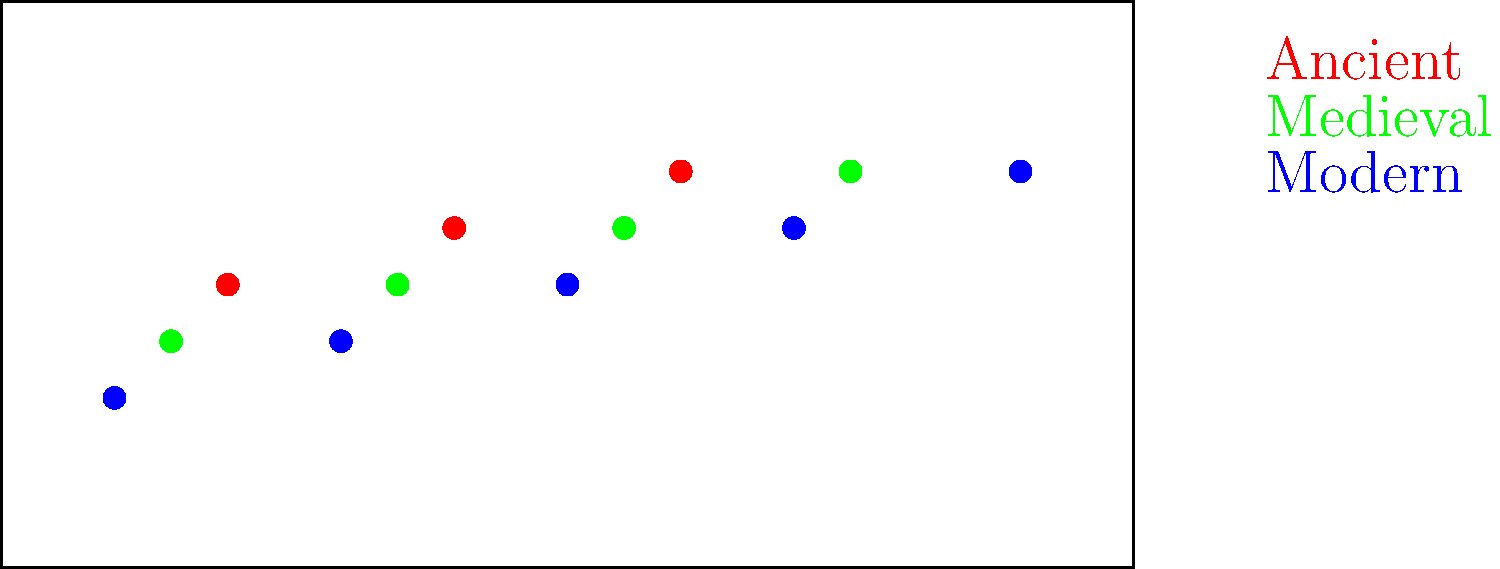Based on the world map showing the geographical spread of Jewish diaspora communities over time, which period demonstrates the most extensive dispersion of Jewish communities? To answer this question, we need to analyze the map and compare the distribution of Jewish communities across different time periods:

1. Ancient period (red dots):
   - Shows 3 main communities
   - Concentrated in a relatively small area

2. Medieval period (green dots):
   - Shows 4 communities
   - Slightly more spread out than the ancient period

3. Modern period (blue dots):
   - Shows 5 communities
   - Most widely distributed across the map

By comparing these three periods, we can observe that:
- The number of communities increases over time
- The geographical spread becomes wider with each period

The modern period (blue dots) clearly shows the most extensive dispersion, with communities spread across a larger geographical area and in greater numbers than the previous periods.
Answer: Modern period 